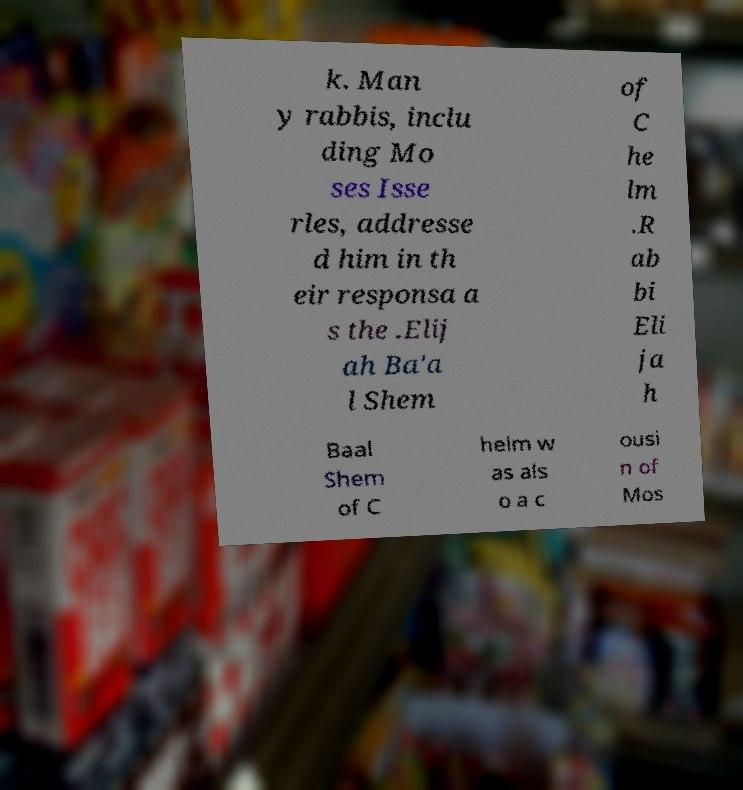For documentation purposes, I need the text within this image transcribed. Could you provide that? k. Man y rabbis, inclu ding Mo ses Isse rles, addresse d him in th eir responsa a s the .Elij ah Ba'a l Shem of C he lm .R ab bi Eli ja h Baal Shem of C helm w as als o a c ousi n of Mos 